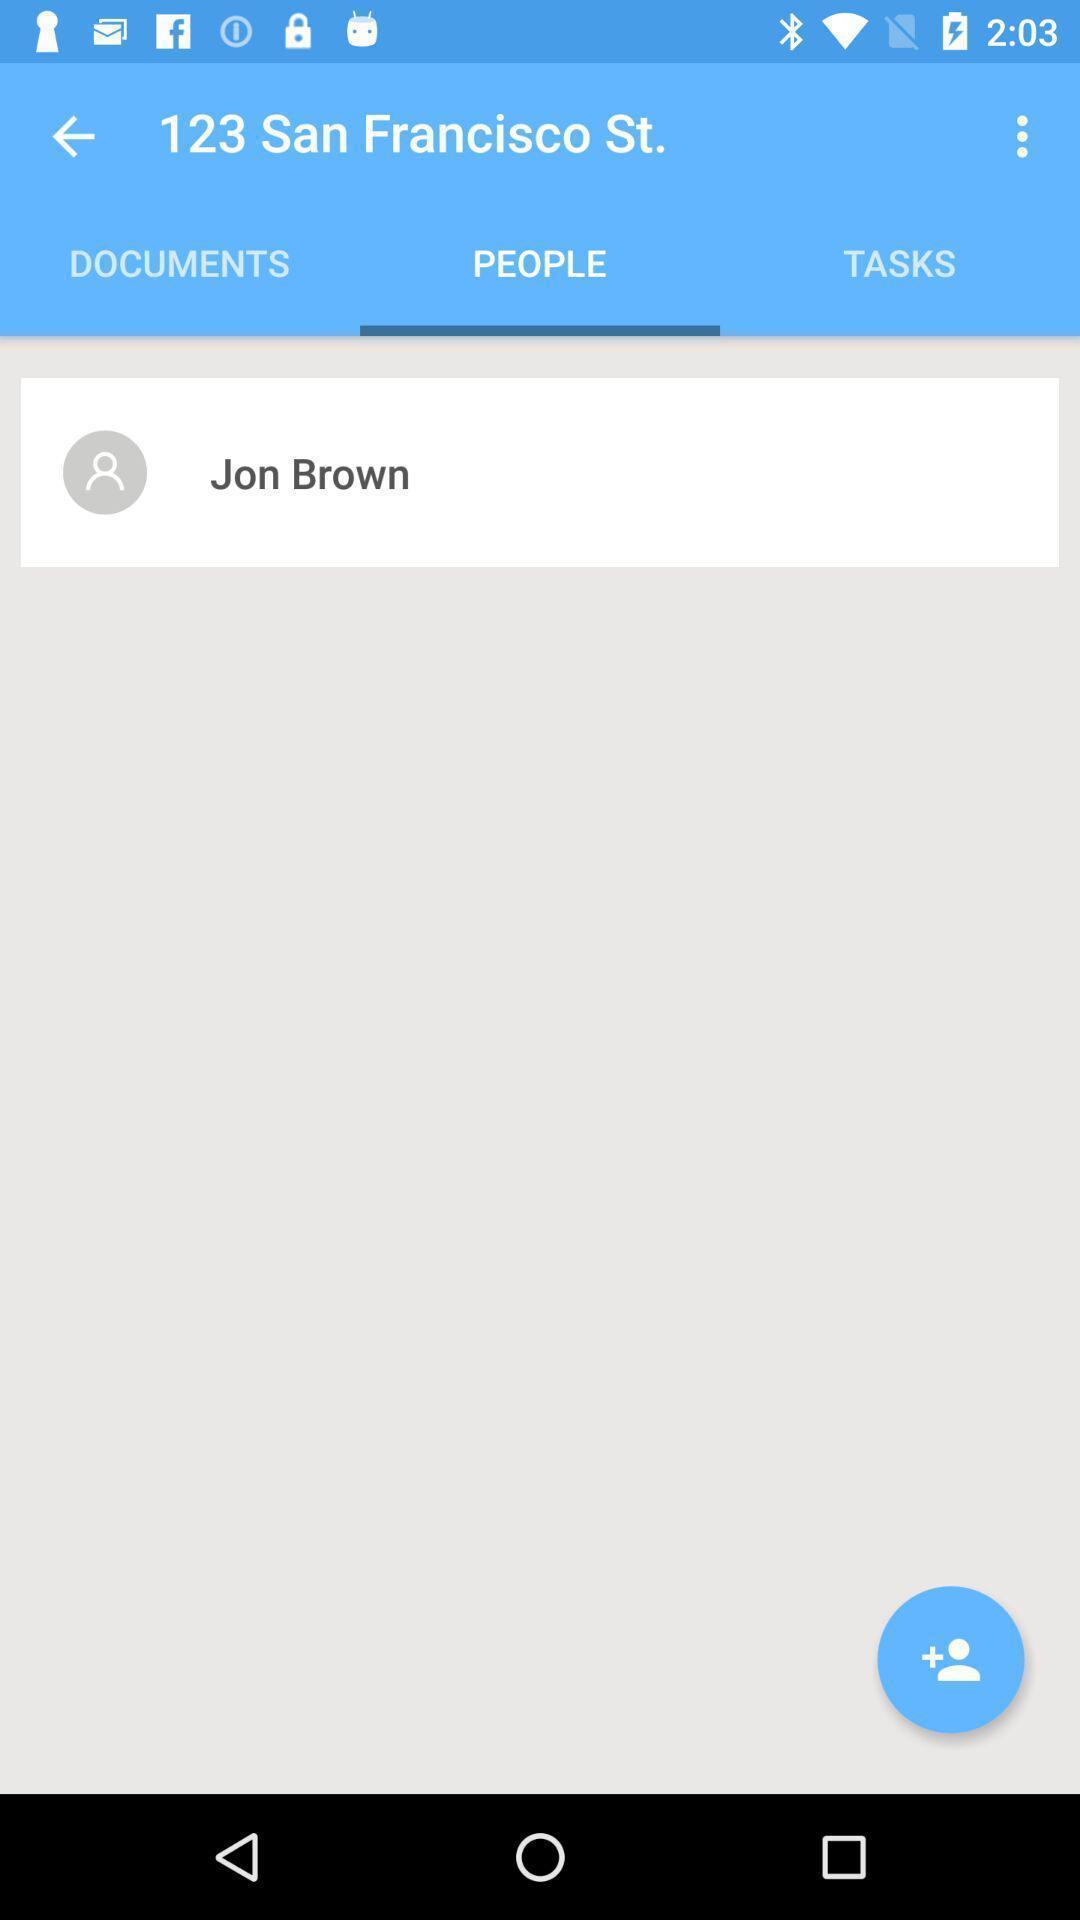Provide a textual representation of this image. Screen displaying people page in app. 